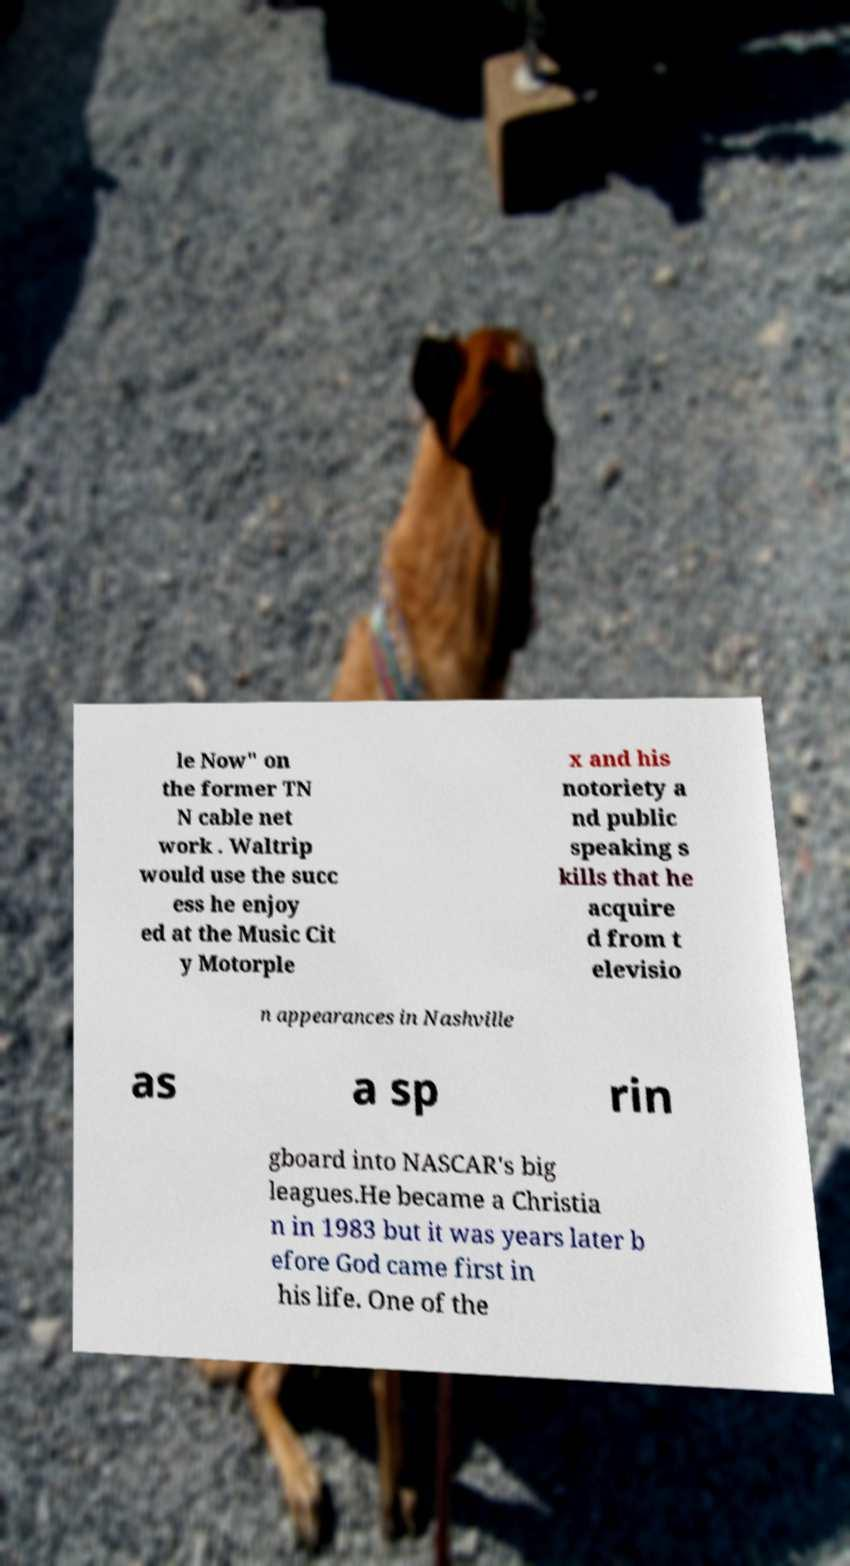Please read and relay the text visible in this image. What does it say? le Now" on the former TN N cable net work . Waltrip would use the succ ess he enjoy ed at the Music Cit y Motorple x and his notoriety a nd public speaking s kills that he acquire d from t elevisio n appearances in Nashville as a sp rin gboard into NASCAR's big leagues.He became a Christia n in 1983 but it was years later b efore God came first in his life. One of the 